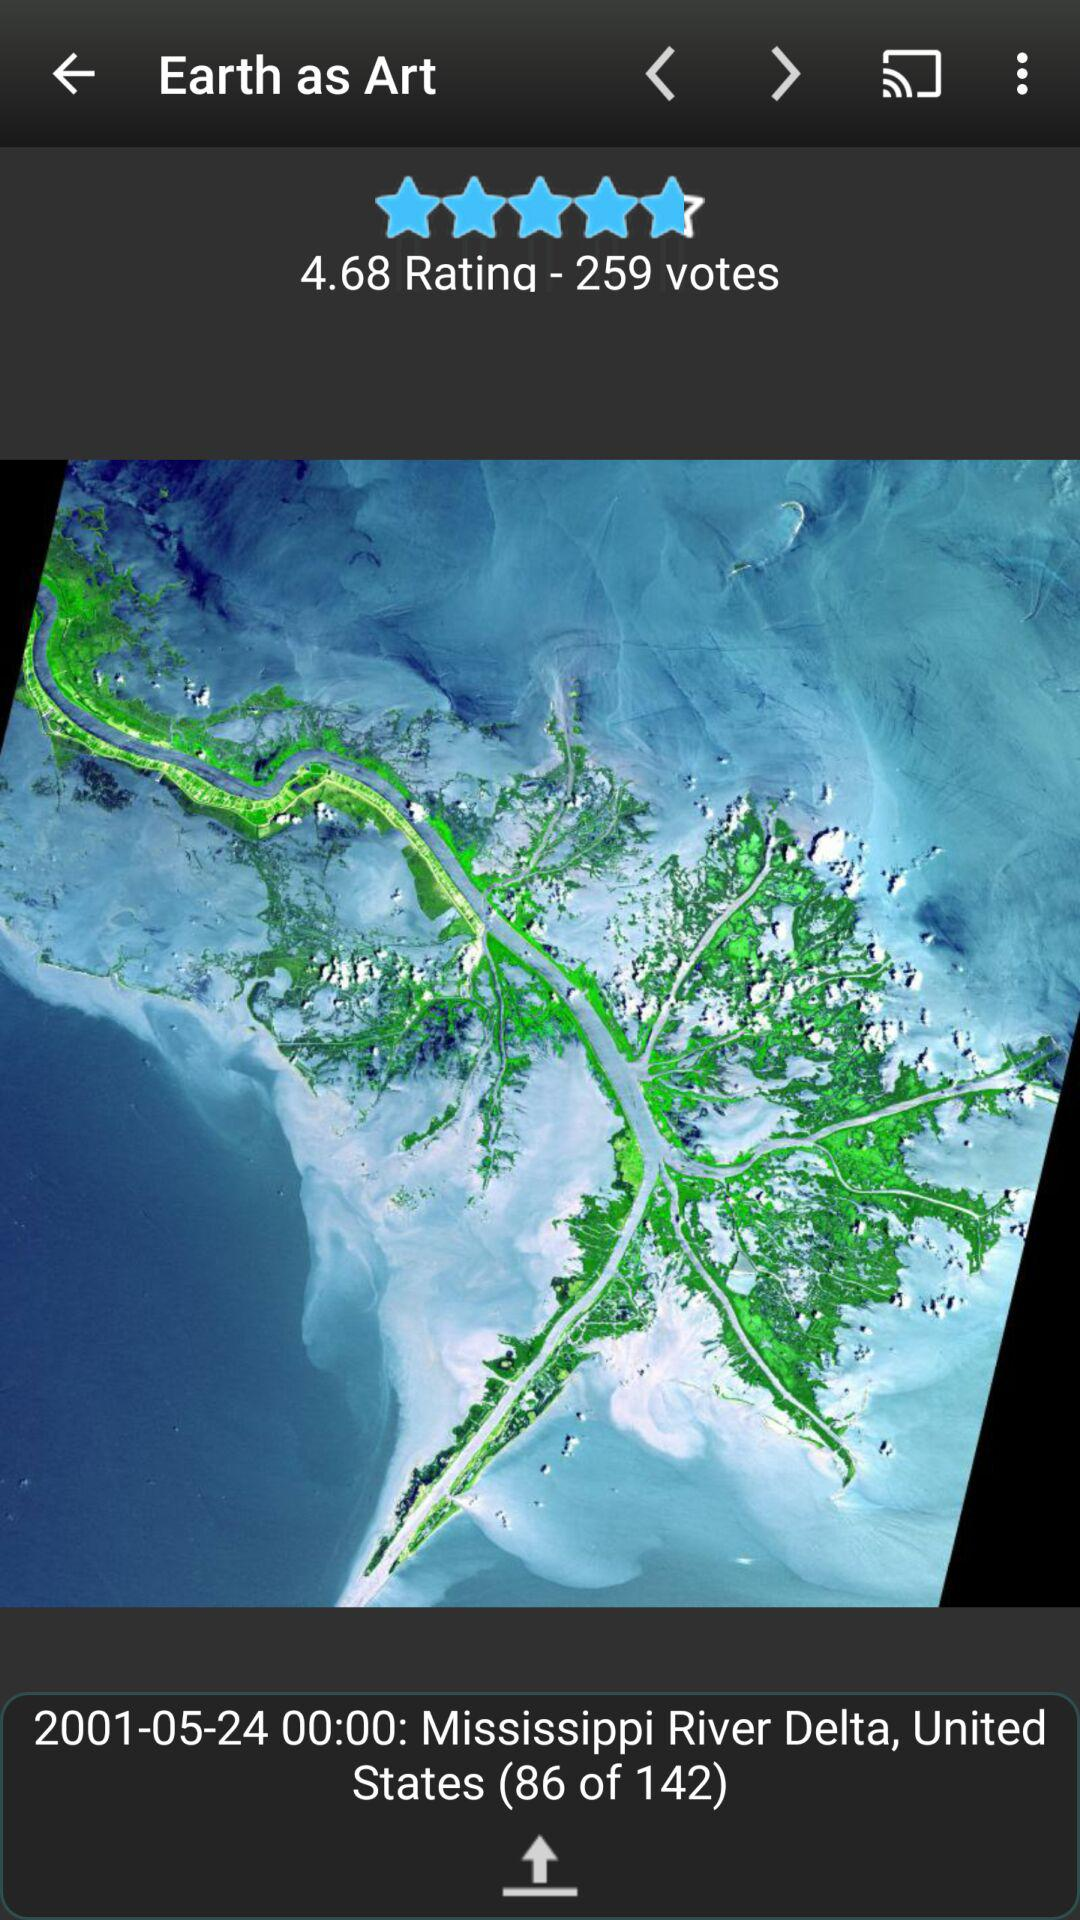What is the rating? The rating is 4.68. 